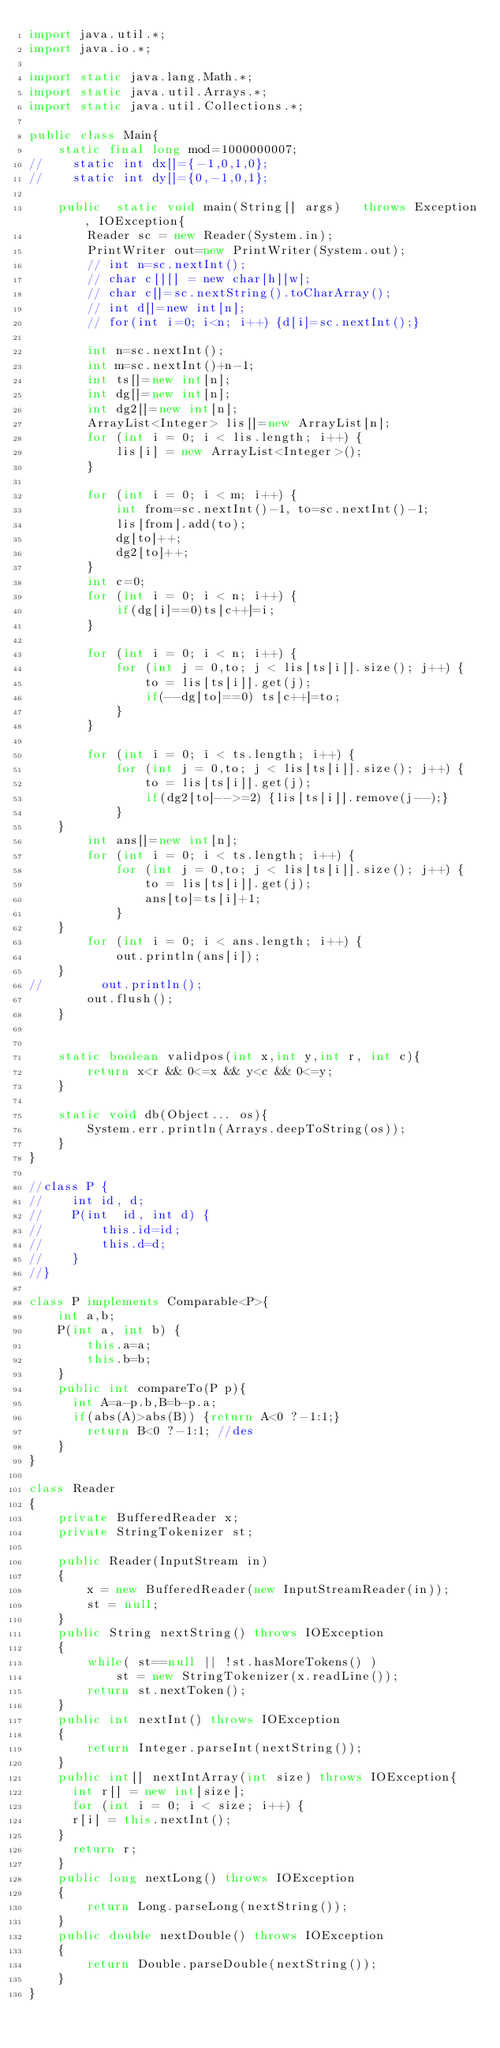Convert code to text. <code><loc_0><loc_0><loc_500><loc_500><_Java_>import java.util.*;
import java.io.*;

import static java.lang.Math.*;
import static java.util.Arrays.*;
import static java.util.Collections.*;
 
public class Main{
    static final long mod=1000000007;
//    static int dx[]={-1,0,1,0};
//    static int dy[]={0,-1,0,1};

    public  static void main(String[] args)   throws Exception, IOException{        
        Reader sc = new Reader(System.in);
        PrintWriter out=new PrintWriter(System.out);
        // int n=sc.nextInt();
        // char c[][] = new char[h][w];
        // char c[]=sc.nextString().toCharArray();
        // int d[]=new int[n];
        // for(int i=0; i<n; i++) {d[i]=sc.nextInt();}

        int n=sc.nextInt();
        int m=sc.nextInt()+n-1;
        int ts[]=new int[n];
        int dg[]=new int[n];
        int dg2[]=new int[n];
        ArrayList<Integer> lis[]=new ArrayList[n];
        for (int i = 0; i < lis.length; i++) {
            lis[i] = new ArrayList<Integer>();
        }

        for (int i = 0; i < m; i++) {
            int from=sc.nextInt()-1, to=sc.nextInt()-1;
            lis[from].add(to);
            dg[to]++;
            dg2[to]++;
        }
        int c=0;
        for (int i = 0; i < n; i++) {
            if(dg[i]==0)ts[c++]=i;
        }

        for (int i = 0; i < n; i++) {
            for (int j = 0,to; j < lis[ts[i]].size(); j++) {
                to = lis[ts[i]].get(j);
                if(--dg[to]==0) ts[c++]=to;
            }
        }
        
        for (int i = 0; i < ts.length; i++) {
            for (int j = 0,to; j < lis[ts[i]].size(); j++) {
                to = lis[ts[i]].get(j);
                if(dg2[to]-->=2) {lis[ts[i]].remove(j--);}
            }			
		}
        int ans[]=new int[n];
        for (int i = 0; i < ts.length; i++) {
            for (int j = 0,to; j < lis[ts[i]].size(); j++) {
                to = lis[ts[i]].get(j);
                ans[to]=ts[i]+1;
            }
		}
        for (int i = 0; i < ans.length; i++) {
            out.println(ans[i]);
		}
//        out.println();
        out.flush();
    }
    
    
    static boolean validpos(int x,int y,int r, int c){
        return x<r && 0<=x && y<c && 0<=y;
    }

    static void db(Object... os){
        System.err.println(Arrays.deepToString(os));
    }  
}

//class P {
//    int id, d;
//    P(int  id, int d) {
//        this.id=id;
//        this.d=d;
//    }
//}

class P implements Comparable<P>{
    int a,b;
    P(int a, int b) {
        this.a=a;
        this.b=b;
    }
    public int compareTo(P p){
    	int A=a-p.b,B=b-p.a;
    	if(abs(A)>abs(B)) {return A<0 ?-1:1;}
        return B<0 ?-1:1; //des
    }
}

class Reader
{ 
    private BufferedReader x;
    private StringTokenizer st;
    
    public Reader(InputStream in)
    {
        x = new BufferedReader(new InputStreamReader(in));
        st = null;
    }
    public String nextString() throws IOException
    {
        while( st==null || !st.hasMoreTokens() )
            st = new StringTokenizer(x.readLine());
        return st.nextToken();
    }
    public int nextInt() throws IOException
    {
        return Integer.parseInt(nextString());
    }
    public int[] nextIntArray(int size) throws IOException{
    	int r[] = new int[size];
    	for (int i = 0; i < size; i++) {
			r[i] = this.nextInt(); 
		}
    	return r;
    }
    public long nextLong() throws IOException
    {
        return Long.parseLong(nextString());
    }
    public double nextDouble() throws IOException
    {
        return Double.parseDouble(nextString());
    }
}
</code> 